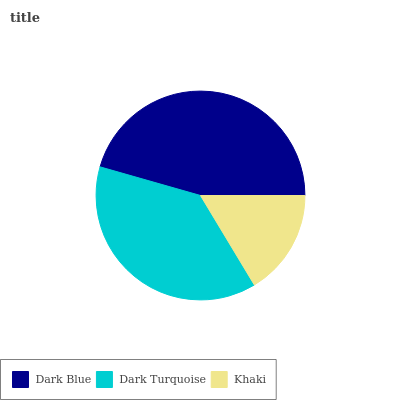Is Khaki the minimum?
Answer yes or no. Yes. Is Dark Blue the maximum?
Answer yes or no. Yes. Is Dark Turquoise the minimum?
Answer yes or no. No. Is Dark Turquoise the maximum?
Answer yes or no. No. Is Dark Blue greater than Dark Turquoise?
Answer yes or no. Yes. Is Dark Turquoise less than Dark Blue?
Answer yes or no. Yes. Is Dark Turquoise greater than Dark Blue?
Answer yes or no. No. Is Dark Blue less than Dark Turquoise?
Answer yes or no. No. Is Dark Turquoise the high median?
Answer yes or no. Yes. Is Dark Turquoise the low median?
Answer yes or no. Yes. Is Dark Blue the high median?
Answer yes or no. No. Is Dark Blue the low median?
Answer yes or no. No. 